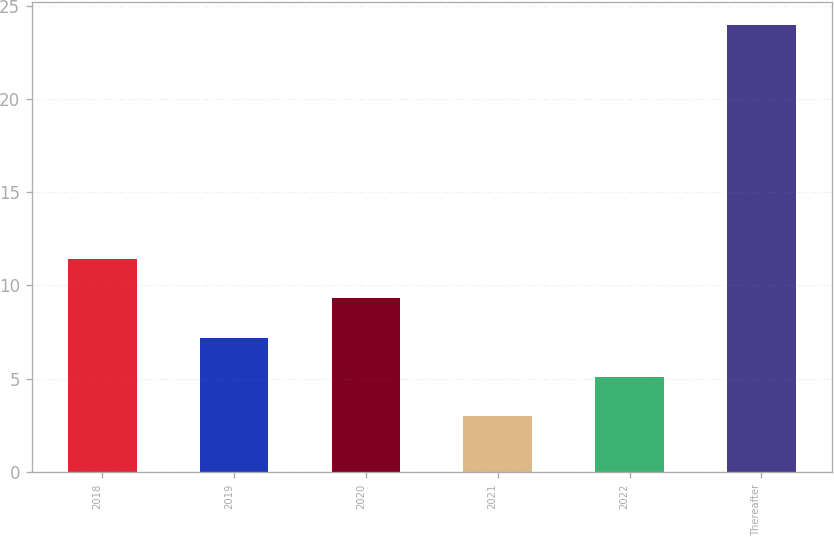<chart> <loc_0><loc_0><loc_500><loc_500><bar_chart><fcel>2018<fcel>2019<fcel>2020<fcel>2021<fcel>2022<fcel>Thereafter<nl><fcel>11.4<fcel>7.2<fcel>9.3<fcel>3<fcel>5.1<fcel>24<nl></chart> 